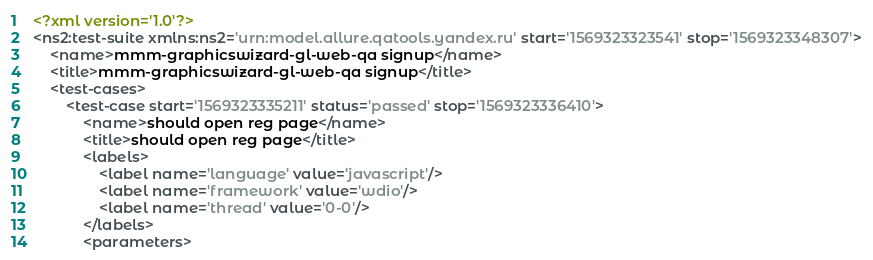<code> <loc_0><loc_0><loc_500><loc_500><_XML_><?xml version='1.0'?>
<ns2:test-suite xmlns:ns2='urn:model.allure.qatools.yandex.ru' start='1569323323541' stop='1569323348307'>
    <name>mmm-graphicswizard-gl-web-qa signup</name>
    <title>mmm-graphicswizard-gl-web-qa signup</title>
    <test-cases>
        <test-case start='1569323335211' status='passed' stop='1569323336410'>
            <name>should open reg page</name>
            <title>should open reg page</title>
            <labels>
                <label name='language' value='javascript'/>
                <label name='framework' value='wdio'/>
                <label name='thread' value='0-0'/>
            </labels>
            <parameters></code> 